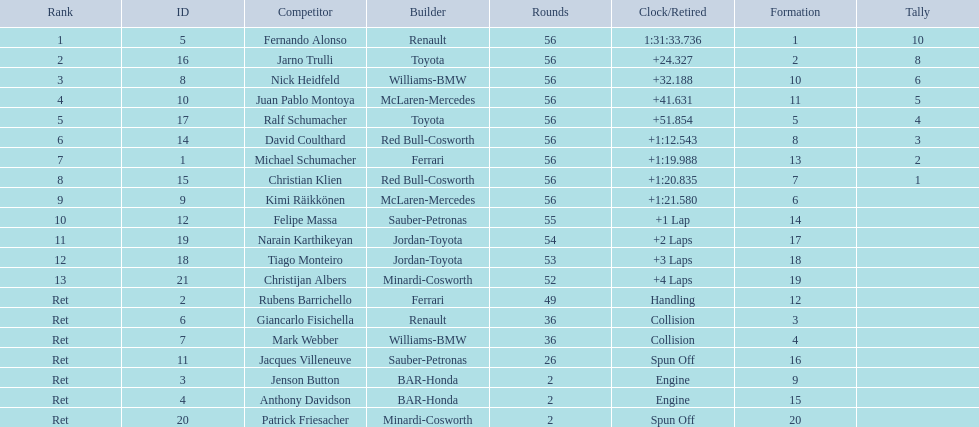What place did fernando alonso finish? 1. How long did it take alonso to finish the race? 1:31:33.736. 